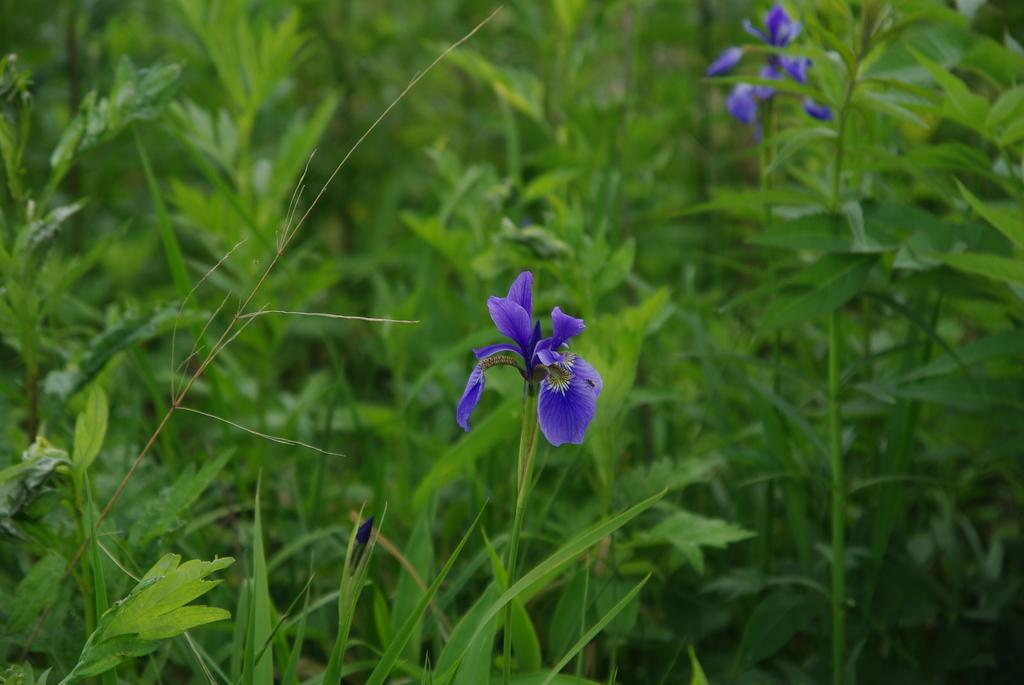What type of living organisms can be seen in the image? There are flowers and plants in the image. Can you describe the plants in the image? The plants in the image are not specified, but they are present alongside the flowers. What type of chin can be seen on the flowers in the image? There are no chins present in the image, as flowers do not have chins. Are the flowers in the image smiling? Flowers do not have facial expressions, so they cannot smile. 